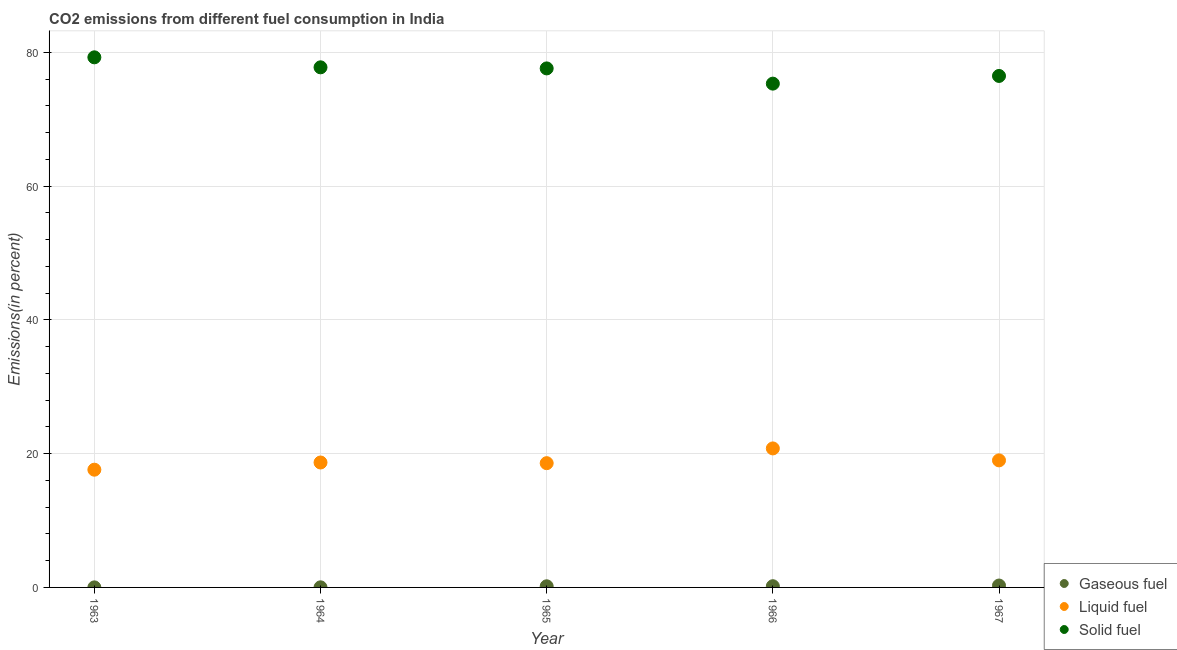How many different coloured dotlines are there?
Your answer should be compact. 3. What is the percentage of solid fuel emission in 1967?
Ensure brevity in your answer.  76.49. Across all years, what is the maximum percentage of solid fuel emission?
Your answer should be compact. 79.27. Across all years, what is the minimum percentage of liquid fuel emission?
Your answer should be very brief. 17.61. In which year was the percentage of gaseous fuel emission maximum?
Keep it short and to the point. 1967. In which year was the percentage of solid fuel emission minimum?
Provide a short and direct response. 1966. What is the total percentage of liquid fuel emission in the graph?
Keep it short and to the point. 94.66. What is the difference between the percentage of liquid fuel emission in 1965 and that in 1966?
Your response must be concise. -2.21. What is the difference between the percentage of gaseous fuel emission in 1965 and the percentage of liquid fuel emission in 1967?
Offer a terse response. -18.83. What is the average percentage of solid fuel emission per year?
Your answer should be very brief. 77.3. In the year 1965, what is the difference between the percentage of solid fuel emission and percentage of liquid fuel emission?
Your response must be concise. 59.03. In how many years, is the percentage of gaseous fuel emission greater than 60 %?
Give a very brief answer. 0. What is the ratio of the percentage of gaseous fuel emission in 1965 to that in 1966?
Give a very brief answer. 0.94. What is the difference between the highest and the second highest percentage of gaseous fuel emission?
Make the answer very short. 0.1. What is the difference between the highest and the lowest percentage of liquid fuel emission?
Your answer should be compact. 3.18. Is the sum of the percentage of solid fuel emission in 1965 and 1966 greater than the maximum percentage of liquid fuel emission across all years?
Your answer should be very brief. Yes. Is it the case that in every year, the sum of the percentage of gaseous fuel emission and percentage of liquid fuel emission is greater than the percentage of solid fuel emission?
Your answer should be compact. No. How many dotlines are there?
Keep it short and to the point. 3. Where does the legend appear in the graph?
Your answer should be compact. Bottom right. How are the legend labels stacked?
Your answer should be very brief. Vertical. What is the title of the graph?
Your response must be concise. CO2 emissions from different fuel consumption in India. Does "Maunufacturing" appear as one of the legend labels in the graph?
Offer a terse response. No. What is the label or title of the Y-axis?
Your answer should be compact. Emissions(in percent). What is the Emissions(in percent) of Gaseous fuel in 1963?
Offer a very short reply. 0.01. What is the Emissions(in percent) of Liquid fuel in 1963?
Offer a terse response. 17.61. What is the Emissions(in percent) in Solid fuel in 1963?
Your response must be concise. 79.27. What is the Emissions(in percent) in Gaseous fuel in 1964?
Provide a short and direct response. 0.01. What is the Emissions(in percent) in Liquid fuel in 1964?
Ensure brevity in your answer.  18.68. What is the Emissions(in percent) of Solid fuel in 1964?
Offer a terse response. 77.78. What is the Emissions(in percent) of Gaseous fuel in 1965?
Offer a very short reply. 0.17. What is the Emissions(in percent) in Liquid fuel in 1965?
Your answer should be compact. 18.58. What is the Emissions(in percent) in Solid fuel in 1965?
Keep it short and to the point. 77.61. What is the Emissions(in percent) in Gaseous fuel in 1966?
Offer a terse response. 0.18. What is the Emissions(in percent) in Liquid fuel in 1966?
Make the answer very short. 20.79. What is the Emissions(in percent) of Solid fuel in 1966?
Ensure brevity in your answer.  75.34. What is the Emissions(in percent) of Gaseous fuel in 1967?
Provide a succinct answer. 0.28. What is the Emissions(in percent) of Liquid fuel in 1967?
Your answer should be compact. 19. What is the Emissions(in percent) in Solid fuel in 1967?
Ensure brevity in your answer.  76.49. Across all years, what is the maximum Emissions(in percent) of Gaseous fuel?
Your response must be concise. 0.28. Across all years, what is the maximum Emissions(in percent) of Liquid fuel?
Your response must be concise. 20.79. Across all years, what is the maximum Emissions(in percent) in Solid fuel?
Provide a succinct answer. 79.27. Across all years, what is the minimum Emissions(in percent) in Gaseous fuel?
Make the answer very short. 0.01. Across all years, what is the minimum Emissions(in percent) in Liquid fuel?
Make the answer very short. 17.61. Across all years, what is the minimum Emissions(in percent) in Solid fuel?
Provide a short and direct response. 75.34. What is the total Emissions(in percent) in Gaseous fuel in the graph?
Provide a short and direct response. 0.66. What is the total Emissions(in percent) of Liquid fuel in the graph?
Your response must be concise. 94.66. What is the total Emissions(in percent) of Solid fuel in the graph?
Provide a succinct answer. 386.49. What is the difference between the Emissions(in percent) of Gaseous fuel in 1963 and that in 1964?
Give a very brief answer. -0.01. What is the difference between the Emissions(in percent) in Liquid fuel in 1963 and that in 1964?
Offer a terse response. -1.08. What is the difference between the Emissions(in percent) of Solid fuel in 1963 and that in 1964?
Your answer should be very brief. 1.5. What is the difference between the Emissions(in percent) in Gaseous fuel in 1963 and that in 1965?
Give a very brief answer. -0.16. What is the difference between the Emissions(in percent) in Liquid fuel in 1963 and that in 1965?
Provide a short and direct response. -0.97. What is the difference between the Emissions(in percent) in Solid fuel in 1963 and that in 1965?
Provide a short and direct response. 1.66. What is the difference between the Emissions(in percent) in Gaseous fuel in 1963 and that in 1966?
Provide a succinct answer. -0.17. What is the difference between the Emissions(in percent) of Liquid fuel in 1963 and that in 1966?
Offer a terse response. -3.18. What is the difference between the Emissions(in percent) in Solid fuel in 1963 and that in 1966?
Ensure brevity in your answer.  3.93. What is the difference between the Emissions(in percent) of Gaseous fuel in 1963 and that in 1967?
Keep it short and to the point. -0.28. What is the difference between the Emissions(in percent) in Liquid fuel in 1963 and that in 1967?
Keep it short and to the point. -1.39. What is the difference between the Emissions(in percent) in Solid fuel in 1963 and that in 1967?
Provide a short and direct response. 2.78. What is the difference between the Emissions(in percent) of Gaseous fuel in 1964 and that in 1965?
Your answer should be compact. -0.16. What is the difference between the Emissions(in percent) of Liquid fuel in 1964 and that in 1965?
Provide a succinct answer. 0.1. What is the difference between the Emissions(in percent) of Solid fuel in 1964 and that in 1965?
Provide a succinct answer. 0.16. What is the difference between the Emissions(in percent) of Gaseous fuel in 1964 and that in 1966?
Keep it short and to the point. -0.17. What is the difference between the Emissions(in percent) of Liquid fuel in 1964 and that in 1966?
Provide a short and direct response. -2.11. What is the difference between the Emissions(in percent) of Solid fuel in 1964 and that in 1966?
Provide a succinct answer. 2.44. What is the difference between the Emissions(in percent) in Gaseous fuel in 1964 and that in 1967?
Offer a very short reply. -0.27. What is the difference between the Emissions(in percent) in Liquid fuel in 1964 and that in 1967?
Offer a terse response. -0.32. What is the difference between the Emissions(in percent) in Solid fuel in 1964 and that in 1967?
Your answer should be compact. 1.29. What is the difference between the Emissions(in percent) of Gaseous fuel in 1965 and that in 1966?
Provide a succinct answer. -0.01. What is the difference between the Emissions(in percent) in Liquid fuel in 1965 and that in 1966?
Give a very brief answer. -2.21. What is the difference between the Emissions(in percent) of Solid fuel in 1965 and that in 1966?
Your answer should be compact. 2.28. What is the difference between the Emissions(in percent) in Gaseous fuel in 1965 and that in 1967?
Your response must be concise. -0.11. What is the difference between the Emissions(in percent) of Liquid fuel in 1965 and that in 1967?
Keep it short and to the point. -0.42. What is the difference between the Emissions(in percent) of Solid fuel in 1965 and that in 1967?
Offer a very short reply. 1.13. What is the difference between the Emissions(in percent) of Gaseous fuel in 1966 and that in 1967?
Offer a terse response. -0.1. What is the difference between the Emissions(in percent) of Liquid fuel in 1966 and that in 1967?
Offer a terse response. 1.79. What is the difference between the Emissions(in percent) in Solid fuel in 1966 and that in 1967?
Offer a very short reply. -1.15. What is the difference between the Emissions(in percent) of Gaseous fuel in 1963 and the Emissions(in percent) of Liquid fuel in 1964?
Keep it short and to the point. -18.68. What is the difference between the Emissions(in percent) of Gaseous fuel in 1963 and the Emissions(in percent) of Solid fuel in 1964?
Provide a short and direct response. -77.77. What is the difference between the Emissions(in percent) of Liquid fuel in 1963 and the Emissions(in percent) of Solid fuel in 1964?
Give a very brief answer. -60.17. What is the difference between the Emissions(in percent) in Gaseous fuel in 1963 and the Emissions(in percent) in Liquid fuel in 1965?
Give a very brief answer. -18.57. What is the difference between the Emissions(in percent) in Gaseous fuel in 1963 and the Emissions(in percent) in Solid fuel in 1965?
Ensure brevity in your answer.  -77.61. What is the difference between the Emissions(in percent) in Liquid fuel in 1963 and the Emissions(in percent) in Solid fuel in 1965?
Give a very brief answer. -60.01. What is the difference between the Emissions(in percent) in Gaseous fuel in 1963 and the Emissions(in percent) in Liquid fuel in 1966?
Offer a terse response. -20.78. What is the difference between the Emissions(in percent) of Gaseous fuel in 1963 and the Emissions(in percent) of Solid fuel in 1966?
Your answer should be very brief. -75.33. What is the difference between the Emissions(in percent) in Liquid fuel in 1963 and the Emissions(in percent) in Solid fuel in 1966?
Provide a short and direct response. -57.73. What is the difference between the Emissions(in percent) of Gaseous fuel in 1963 and the Emissions(in percent) of Liquid fuel in 1967?
Make the answer very short. -18.99. What is the difference between the Emissions(in percent) of Gaseous fuel in 1963 and the Emissions(in percent) of Solid fuel in 1967?
Ensure brevity in your answer.  -76.48. What is the difference between the Emissions(in percent) of Liquid fuel in 1963 and the Emissions(in percent) of Solid fuel in 1967?
Provide a succinct answer. -58.88. What is the difference between the Emissions(in percent) in Gaseous fuel in 1964 and the Emissions(in percent) in Liquid fuel in 1965?
Keep it short and to the point. -18.57. What is the difference between the Emissions(in percent) of Gaseous fuel in 1964 and the Emissions(in percent) of Solid fuel in 1965?
Offer a very short reply. -77.6. What is the difference between the Emissions(in percent) of Liquid fuel in 1964 and the Emissions(in percent) of Solid fuel in 1965?
Provide a succinct answer. -58.93. What is the difference between the Emissions(in percent) in Gaseous fuel in 1964 and the Emissions(in percent) in Liquid fuel in 1966?
Provide a short and direct response. -20.77. What is the difference between the Emissions(in percent) in Gaseous fuel in 1964 and the Emissions(in percent) in Solid fuel in 1966?
Provide a short and direct response. -75.32. What is the difference between the Emissions(in percent) in Liquid fuel in 1964 and the Emissions(in percent) in Solid fuel in 1966?
Ensure brevity in your answer.  -56.66. What is the difference between the Emissions(in percent) in Gaseous fuel in 1964 and the Emissions(in percent) in Liquid fuel in 1967?
Offer a very short reply. -18.98. What is the difference between the Emissions(in percent) in Gaseous fuel in 1964 and the Emissions(in percent) in Solid fuel in 1967?
Your response must be concise. -76.47. What is the difference between the Emissions(in percent) of Liquid fuel in 1964 and the Emissions(in percent) of Solid fuel in 1967?
Make the answer very short. -57.8. What is the difference between the Emissions(in percent) in Gaseous fuel in 1965 and the Emissions(in percent) in Liquid fuel in 1966?
Ensure brevity in your answer.  -20.62. What is the difference between the Emissions(in percent) in Gaseous fuel in 1965 and the Emissions(in percent) in Solid fuel in 1966?
Provide a succinct answer. -75.17. What is the difference between the Emissions(in percent) in Liquid fuel in 1965 and the Emissions(in percent) in Solid fuel in 1966?
Offer a very short reply. -56.76. What is the difference between the Emissions(in percent) of Gaseous fuel in 1965 and the Emissions(in percent) of Liquid fuel in 1967?
Your response must be concise. -18.83. What is the difference between the Emissions(in percent) in Gaseous fuel in 1965 and the Emissions(in percent) in Solid fuel in 1967?
Make the answer very short. -76.32. What is the difference between the Emissions(in percent) of Liquid fuel in 1965 and the Emissions(in percent) of Solid fuel in 1967?
Offer a very short reply. -57.91. What is the difference between the Emissions(in percent) in Gaseous fuel in 1966 and the Emissions(in percent) in Liquid fuel in 1967?
Your answer should be very brief. -18.82. What is the difference between the Emissions(in percent) of Gaseous fuel in 1966 and the Emissions(in percent) of Solid fuel in 1967?
Your answer should be very brief. -76.31. What is the difference between the Emissions(in percent) of Liquid fuel in 1966 and the Emissions(in percent) of Solid fuel in 1967?
Give a very brief answer. -55.7. What is the average Emissions(in percent) of Gaseous fuel per year?
Offer a very short reply. 0.13. What is the average Emissions(in percent) in Liquid fuel per year?
Provide a succinct answer. 18.93. What is the average Emissions(in percent) in Solid fuel per year?
Provide a succinct answer. 77.3. In the year 1963, what is the difference between the Emissions(in percent) in Gaseous fuel and Emissions(in percent) in Liquid fuel?
Ensure brevity in your answer.  -17.6. In the year 1963, what is the difference between the Emissions(in percent) of Gaseous fuel and Emissions(in percent) of Solid fuel?
Make the answer very short. -79.26. In the year 1963, what is the difference between the Emissions(in percent) in Liquid fuel and Emissions(in percent) in Solid fuel?
Ensure brevity in your answer.  -61.66. In the year 1964, what is the difference between the Emissions(in percent) of Gaseous fuel and Emissions(in percent) of Liquid fuel?
Your response must be concise. -18.67. In the year 1964, what is the difference between the Emissions(in percent) in Gaseous fuel and Emissions(in percent) in Solid fuel?
Provide a succinct answer. -77.76. In the year 1964, what is the difference between the Emissions(in percent) in Liquid fuel and Emissions(in percent) in Solid fuel?
Offer a terse response. -59.09. In the year 1965, what is the difference between the Emissions(in percent) in Gaseous fuel and Emissions(in percent) in Liquid fuel?
Ensure brevity in your answer.  -18.41. In the year 1965, what is the difference between the Emissions(in percent) in Gaseous fuel and Emissions(in percent) in Solid fuel?
Offer a very short reply. -77.44. In the year 1965, what is the difference between the Emissions(in percent) in Liquid fuel and Emissions(in percent) in Solid fuel?
Provide a succinct answer. -59.03. In the year 1966, what is the difference between the Emissions(in percent) of Gaseous fuel and Emissions(in percent) of Liquid fuel?
Provide a succinct answer. -20.61. In the year 1966, what is the difference between the Emissions(in percent) of Gaseous fuel and Emissions(in percent) of Solid fuel?
Provide a short and direct response. -75.16. In the year 1966, what is the difference between the Emissions(in percent) of Liquid fuel and Emissions(in percent) of Solid fuel?
Offer a terse response. -54.55. In the year 1967, what is the difference between the Emissions(in percent) in Gaseous fuel and Emissions(in percent) in Liquid fuel?
Make the answer very short. -18.72. In the year 1967, what is the difference between the Emissions(in percent) in Gaseous fuel and Emissions(in percent) in Solid fuel?
Your answer should be compact. -76.2. In the year 1967, what is the difference between the Emissions(in percent) in Liquid fuel and Emissions(in percent) in Solid fuel?
Your answer should be compact. -57.49. What is the ratio of the Emissions(in percent) of Gaseous fuel in 1963 to that in 1964?
Offer a terse response. 0.49. What is the ratio of the Emissions(in percent) of Liquid fuel in 1963 to that in 1964?
Make the answer very short. 0.94. What is the ratio of the Emissions(in percent) of Solid fuel in 1963 to that in 1964?
Give a very brief answer. 1.02. What is the ratio of the Emissions(in percent) in Gaseous fuel in 1963 to that in 1965?
Provide a succinct answer. 0.04. What is the ratio of the Emissions(in percent) in Liquid fuel in 1963 to that in 1965?
Make the answer very short. 0.95. What is the ratio of the Emissions(in percent) in Solid fuel in 1963 to that in 1965?
Offer a terse response. 1.02. What is the ratio of the Emissions(in percent) in Gaseous fuel in 1963 to that in 1966?
Your answer should be very brief. 0.04. What is the ratio of the Emissions(in percent) in Liquid fuel in 1963 to that in 1966?
Your answer should be very brief. 0.85. What is the ratio of the Emissions(in percent) in Solid fuel in 1963 to that in 1966?
Your answer should be very brief. 1.05. What is the ratio of the Emissions(in percent) in Gaseous fuel in 1963 to that in 1967?
Make the answer very short. 0.03. What is the ratio of the Emissions(in percent) in Liquid fuel in 1963 to that in 1967?
Give a very brief answer. 0.93. What is the ratio of the Emissions(in percent) in Solid fuel in 1963 to that in 1967?
Your answer should be compact. 1.04. What is the ratio of the Emissions(in percent) in Gaseous fuel in 1964 to that in 1965?
Offer a terse response. 0.09. What is the ratio of the Emissions(in percent) in Liquid fuel in 1964 to that in 1965?
Give a very brief answer. 1.01. What is the ratio of the Emissions(in percent) of Solid fuel in 1964 to that in 1965?
Keep it short and to the point. 1. What is the ratio of the Emissions(in percent) of Gaseous fuel in 1964 to that in 1966?
Make the answer very short. 0.08. What is the ratio of the Emissions(in percent) of Liquid fuel in 1964 to that in 1966?
Your answer should be compact. 0.9. What is the ratio of the Emissions(in percent) of Solid fuel in 1964 to that in 1966?
Provide a short and direct response. 1.03. What is the ratio of the Emissions(in percent) of Gaseous fuel in 1964 to that in 1967?
Ensure brevity in your answer.  0.05. What is the ratio of the Emissions(in percent) in Liquid fuel in 1964 to that in 1967?
Your answer should be compact. 0.98. What is the ratio of the Emissions(in percent) of Solid fuel in 1964 to that in 1967?
Offer a terse response. 1.02. What is the ratio of the Emissions(in percent) of Gaseous fuel in 1965 to that in 1966?
Your answer should be compact. 0.94. What is the ratio of the Emissions(in percent) of Liquid fuel in 1965 to that in 1966?
Your answer should be very brief. 0.89. What is the ratio of the Emissions(in percent) of Solid fuel in 1965 to that in 1966?
Make the answer very short. 1.03. What is the ratio of the Emissions(in percent) in Gaseous fuel in 1965 to that in 1967?
Offer a terse response. 0.6. What is the ratio of the Emissions(in percent) in Liquid fuel in 1965 to that in 1967?
Give a very brief answer. 0.98. What is the ratio of the Emissions(in percent) in Solid fuel in 1965 to that in 1967?
Offer a very short reply. 1.01. What is the ratio of the Emissions(in percent) of Gaseous fuel in 1966 to that in 1967?
Provide a succinct answer. 0.64. What is the ratio of the Emissions(in percent) of Liquid fuel in 1966 to that in 1967?
Provide a short and direct response. 1.09. What is the ratio of the Emissions(in percent) of Solid fuel in 1966 to that in 1967?
Provide a succinct answer. 0.98. What is the difference between the highest and the second highest Emissions(in percent) in Gaseous fuel?
Offer a terse response. 0.1. What is the difference between the highest and the second highest Emissions(in percent) of Liquid fuel?
Your answer should be very brief. 1.79. What is the difference between the highest and the second highest Emissions(in percent) in Solid fuel?
Keep it short and to the point. 1.5. What is the difference between the highest and the lowest Emissions(in percent) of Gaseous fuel?
Provide a succinct answer. 0.28. What is the difference between the highest and the lowest Emissions(in percent) in Liquid fuel?
Offer a terse response. 3.18. What is the difference between the highest and the lowest Emissions(in percent) in Solid fuel?
Offer a very short reply. 3.93. 